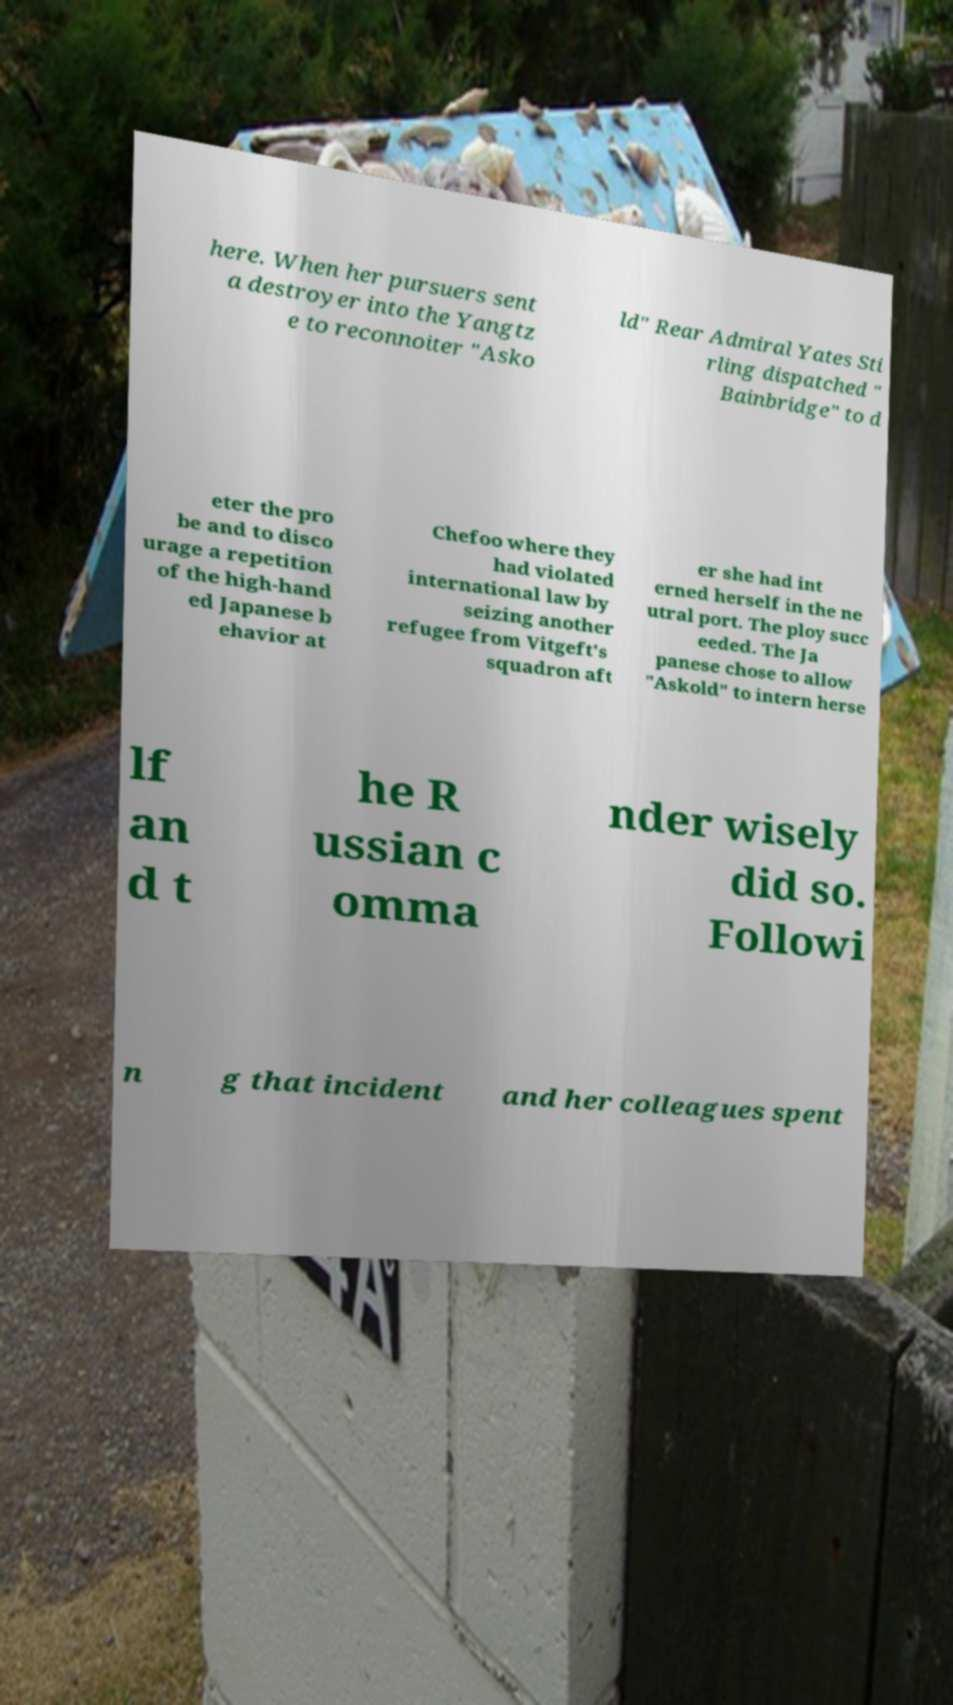What messages or text are displayed in this image? I need them in a readable, typed format. here. When her pursuers sent a destroyer into the Yangtz e to reconnoiter "Asko ld" Rear Admiral Yates Sti rling dispatched " Bainbridge" to d eter the pro be and to disco urage a repetition of the high-hand ed Japanese b ehavior at Chefoo where they had violated international law by seizing another refugee from Vitgeft's squadron aft er she had int erned herself in the ne utral port. The ploy succ eeded. The Ja panese chose to allow "Askold" to intern herse lf an d t he R ussian c omma nder wisely did so. Followi n g that incident and her colleagues spent 